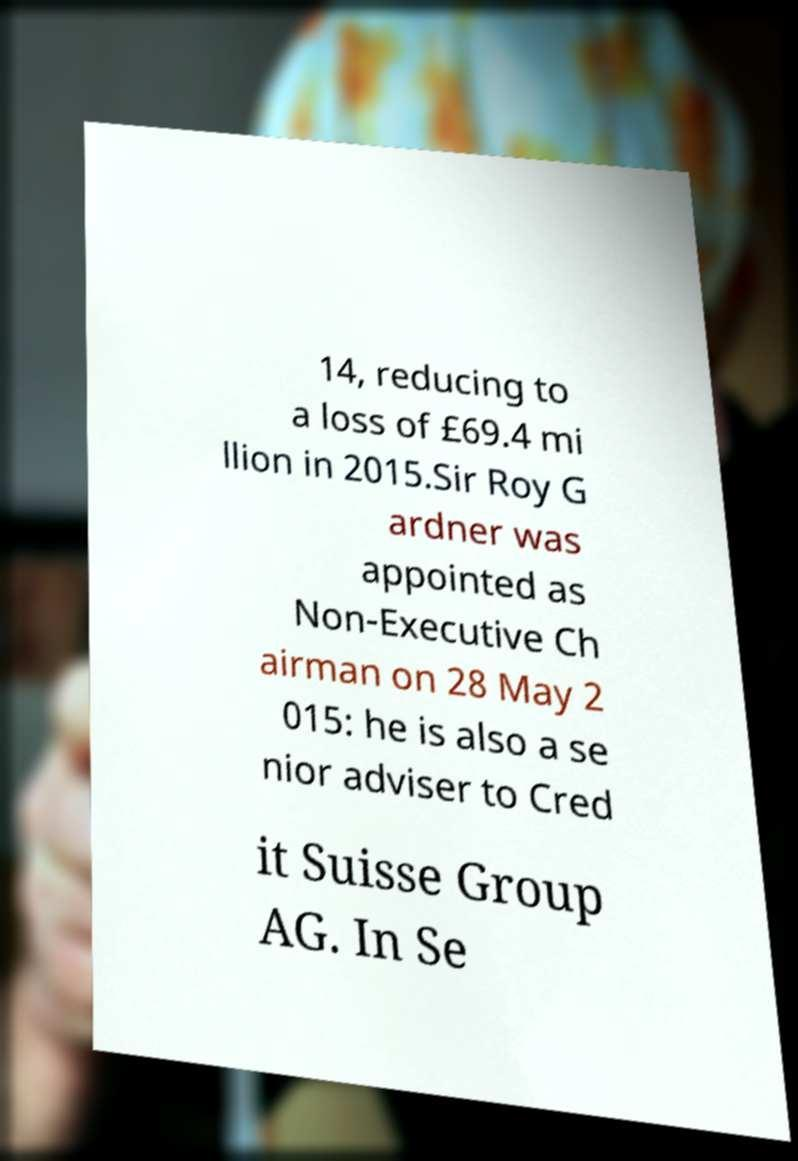Please identify and transcribe the text found in this image. 14, reducing to a loss of £69.4 mi llion in 2015.Sir Roy G ardner was appointed as Non-Executive Ch airman on 28 May 2 015: he is also a se nior adviser to Cred it Suisse Group AG. In Se 